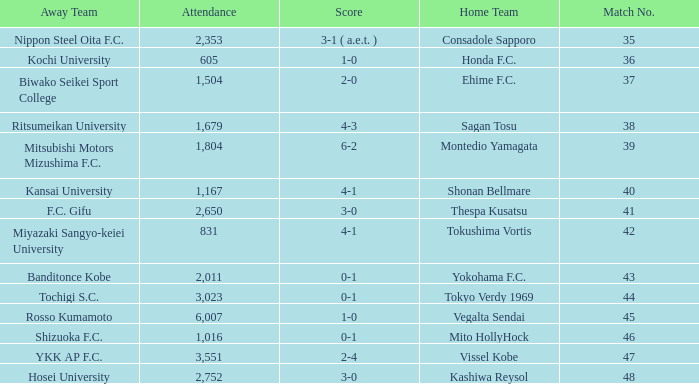After Match 43, what was the Attendance of the Match with a Score of 2-4? 3551.0. 